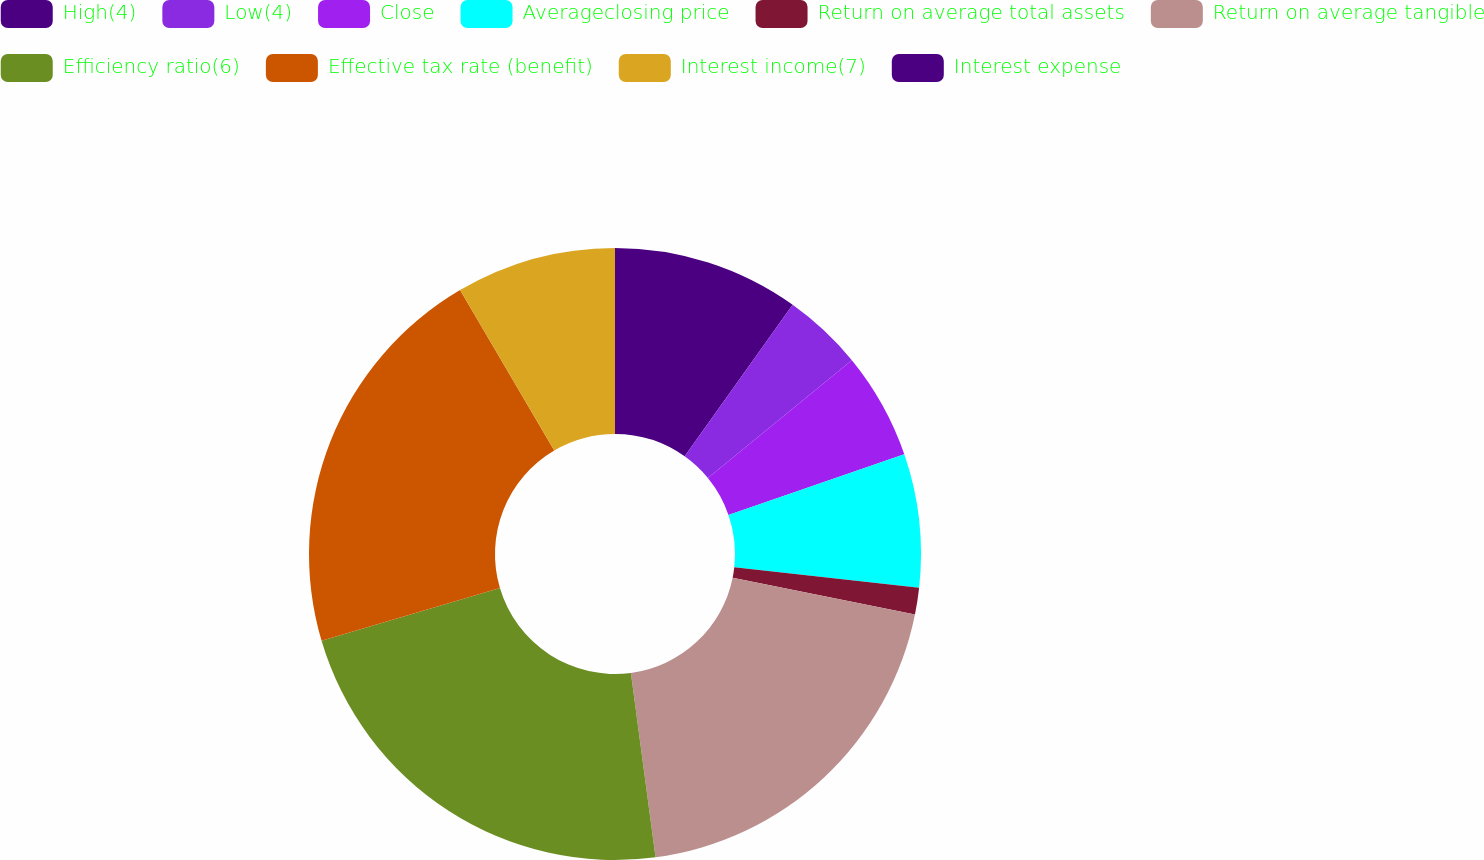Convert chart. <chart><loc_0><loc_0><loc_500><loc_500><pie_chart><fcel>High(4)<fcel>Low(4)<fcel>Close<fcel>Averageclosing price<fcel>Return on average total assets<fcel>Return on average tangible<fcel>Efficiency ratio(6)<fcel>Effective tax rate (benefit)<fcel>Interest income(7)<fcel>Interest expense<nl><fcel>9.86%<fcel>4.23%<fcel>5.63%<fcel>7.04%<fcel>1.41%<fcel>19.72%<fcel>22.54%<fcel>21.13%<fcel>8.45%<fcel>0.0%<nl></chart> 